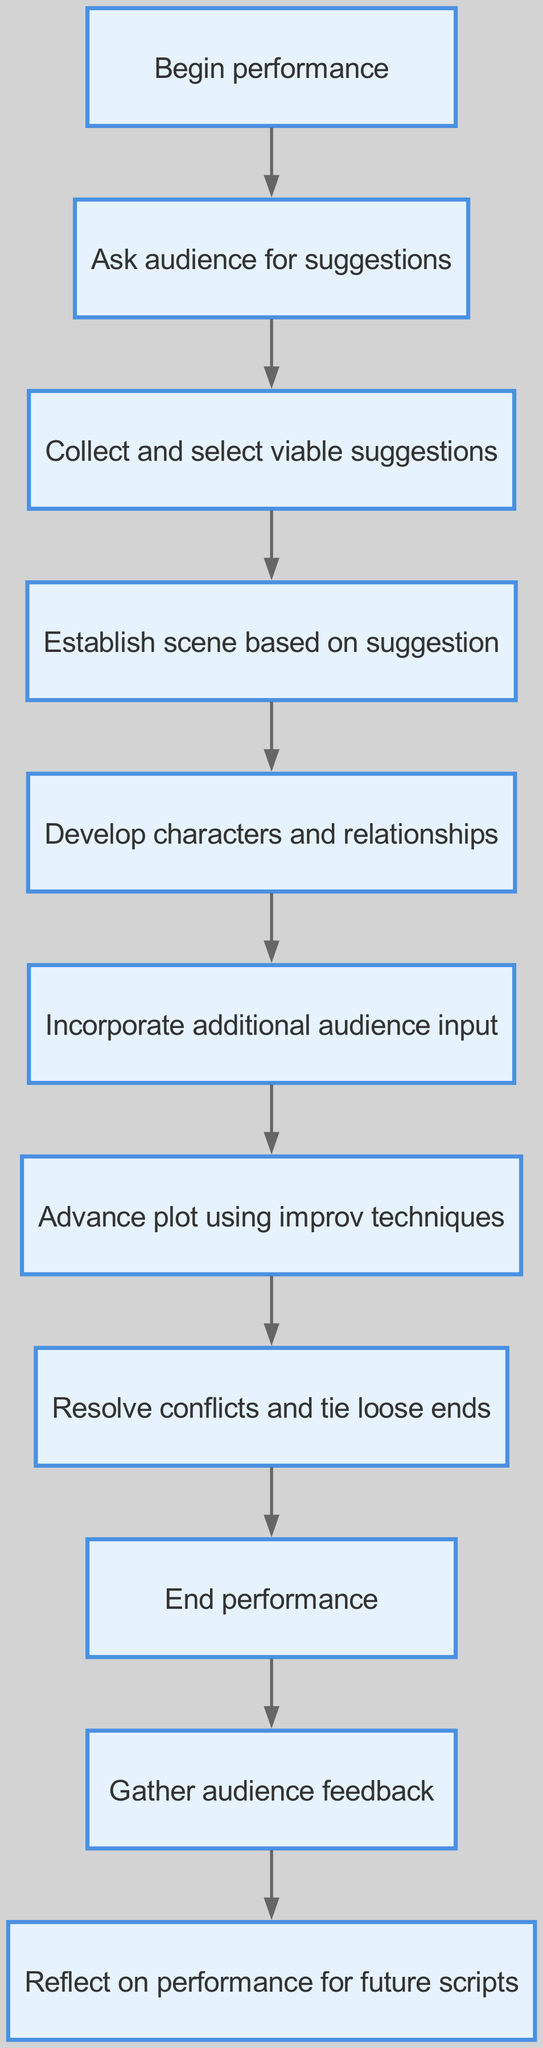What is the first step in the performance? The first step in the flow chart is labeled "Begin performance." It is the starting point of the process that leads through various stages based on audience interaction.
Answer: Begin performance How many nodes are there in total? Counting each element in the provided data structure, there are 11 nodes listed in the diagram, including the start and end steps.
Answer: 11 What step follows "Collect and select viable suggestions”? Following "Collect and select viable suggestions", the next step is "Establish scene based on suggestion." This indicates the transition to framing the performance's context based on the audience's input.
Answer: Establish scene based on suggestion Which step comes before "Advance plot using improv techniques"? The step that precedes "Advance plot using improv techniques" is "Incorporate additional audience input." This shows the order of actions leading to the advancement of the story.
Answer: Incorporate additional audience input What feedback is gathered at the end of the performance? At the end of the performance, the action taken is to "Gather audience feedback." This indicates that audience input at this phase is specifically focused on their experiences and reactions to the performance.
Answer: Gather audience feedback What is the last step in the performance process? The final step outlined in the flow chart is "End performance." This represents the conclusion of the series of actions initiated at the start leading to the finale of the performance.
Answer: End performance What are the two steps that directly follow “Develop characters and relationships”? The two steps that follow "Develop characters and relationships" are "Incorporate additional audience input" and "Advance plot using improv techniques." This shows a progression from character development to plot progression, indicating the importance of audience engagement at both phases.
Answer: Incorporate additional audience input, Advance plot using improv techniques What element is reached after “Resolve conflicts and tie loose ends”? After "Resolve conflicts and tie loose ends", the flow leads directly to "End performance." This signifies that once all conflicts are tackled, the performance can come to a conclusion.
Answer: End performance 